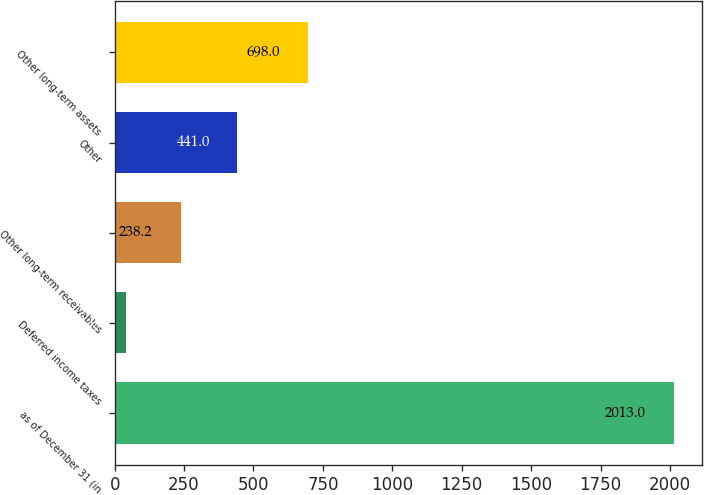Convert chart. <chart><loc_0><loc_0><loc_500><loc_500><bar_chart><fcel>as of December 31 (in<fcel>Deferred income taxes<fcel>Other long-term receivables<fcel>Other<fcel>Other long-term assets<nl><fcel>2013<fcel>41<fcel>238.2<fcel>441<fcel>698<nl></chart> 